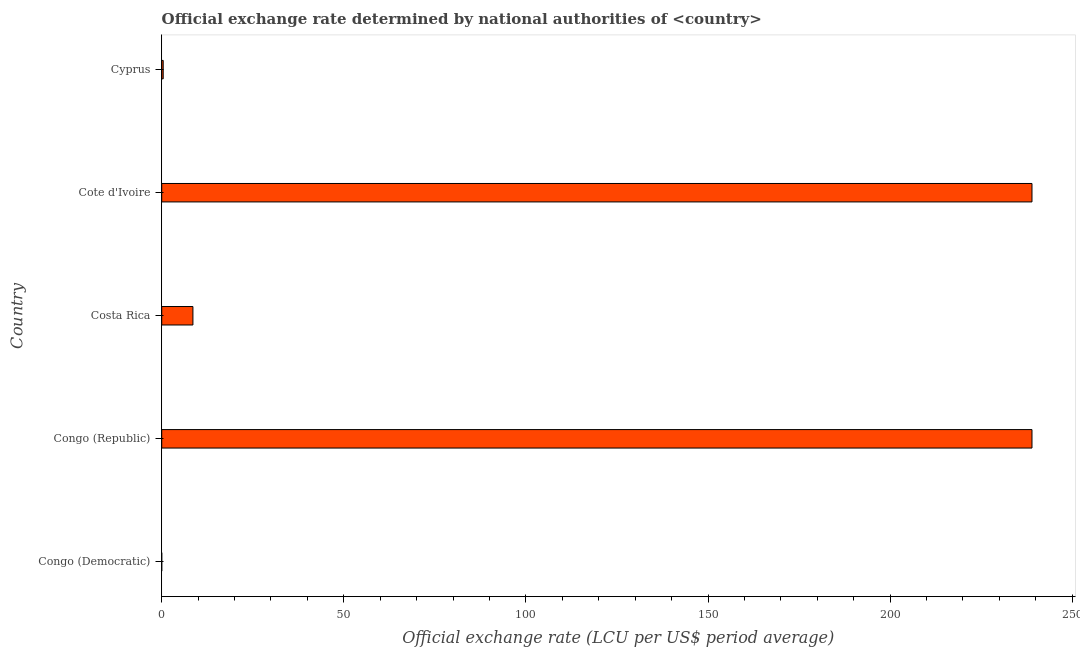Does the graph contain any zero values?
Provide a short and direct response. No. What is the title of the graph?
Keep it short and to the point. Official exchange rate determined by national authorities of <country>. What is the label or title of the X-axis?
Keep it short and to the point. Official exchange rate (LCU per US$ period average). What is the official exchange rate in Costa Rica?
Your answer should be compact. 8.57. Across all countries, what is the maximum official exchange rate?
Your answer should be compact. 238.95. Across all countries, what is the minimum official exchange rate?
Ensure brevity in your answer.  2.64083333333333e-12. In which country was the official exchange rate maximum?
Make the answer very short. Congo (Republic). In which country was the official exchange rate minimum?
Give a very brief answer. Congo (Democratic). What is the sum of the official exchange rate?
Give a very brief answer. 486.88. What is the difference between the official exchange rate in Costa Rica and Cote d'Ivoire?
Your response must be concise. -230.38. What is the average official exchange rate per country?
Provide a succinct answer. 97.38. What is the median official exchange rate?
Offer a very short reply. 8.57. What is the ratio of the official exchange rate in Congo (Republic) to that in Cote d'Ivoire?
Your answer should be very brief. 1. Is the difference between the official exchange rate in Congo (Democratic) and Costa Rica greater than the difference between any two countries?
Offer a terse response. No. What is the difference between the highest and the second highest official exchange rate?
Provide a short and direct response. 0. What is the difference between the highest and the lowest official exchange rate?
Offer a terse response. 238.95. In how many countries, is the official exchange rate greater than the average official exchange rate taken over all countries?
Your answer should be compact. 2. Are all the bars in the graph horizontal?
Offer a terse response. Yes. Are the values on the major ticks of X-axis written in scientific E-notation?
Your answer should be compact. No. What is the Official exchange rate (LCU per US$ period average) in Congo (Democratic)?
Make the answer very short. 2.64083333333333e-12. What is the Official exchange rate (LCU per US$ period average) of Congo (Republic)?
Keep it short and to the point. 238.95. What is the Official exchange rate (LCU per US$ period average) of Costa Rica?
Ensure brevity in your answer.  8.57. What is the Official exchange rate (LCU per US$ period average) in Cote d'Ivoire?
Ensure brevity in your answer.  238.95. What is the Official exchange rate (LCU per US$ period average) of Cyprus?
Provide a short and direct response. 0.41. What is the difference between the Official exchange rate (LCU per US$ period average) in Congo (Democratic) and Congo (Republic)?
Keep it short and to the point. -238.95. What is the difference between the Official exchange rate (LCU per US$ period average) in Congo (Democratic) and Costa Rica?
Your answer should be very brief. -8.57. What is the difference between the Official exchange rate (LCU per US$ period average) in Congo (Democratic) and Cote d'Ivoire?
Offer a very short reply. -238.95. What is the difference between the Official exchange rate (LCU per US$ period average) in Congo (Democratic) and Cyprus?
Offer a terse response. -0.41. What is the difference between the Official exchange rate (LCU per US$ period average) in Congo (Republic) and Costa Rica?
Provide a short and direct response. 230.38. What is the difference between the Official exchange rate (LCU per US$ period average) in Congo (Republic) and Cyprus?
Ensure brevity in your answer.  238.54. What is the difference between the Official exchange rate (LCU per US$ period average) in Costa Rica and Cote d'Ivoire?
Your response must be concise. -230.38. What is the difference between the Official exchange rate (LCU per US$ period average) in Costa Rica and Cyprus?
Your answer should be very brief. 8.16. What is the difference between the Official exchange rate (LCU per US$ period average) in Cote d'Ivoire and Cyprus?
Your response must be concise. 238.54. What is the ratio of the Official exchange rate (LCU per US$ period average) in Congo (Democratic) to that in Cote d'Ivoire?
Keep it short and to the point. 0. What is the ratio of the Official exchange rate (LCU per US$ period average) in Congo (Republic) to that in Costa Rica?
Provide a short and direct response. 27.88. What is the ratio of the Official exchange rate (LCU per US$ period average) in Congo (Republic) to that in Cote d'Ivoire?
Provide a short and direct response. 1. What is the ratio of the Official exchange rate (LCU per US$ period average) in Congo (Republic) to that in Cyprus?
Your answer should be very brief. 582.1. What is the ratio of the Official exchange rate (LCU per US$ period average) in Costa Rica to that in Cote d'Ivoire?
Offer a terse response. 0.04. What is the ratio of the Official exchange rate (LCU per US$ period average) in Costa Rica to that in Cyprus?
Offer a very short reply. 20.88. What is the ratio of the Official exchange rate (LCU per US$ period average) in Cote d'Ivoire to that in Cyprus?
Your answer should be very brief. 582.1. 